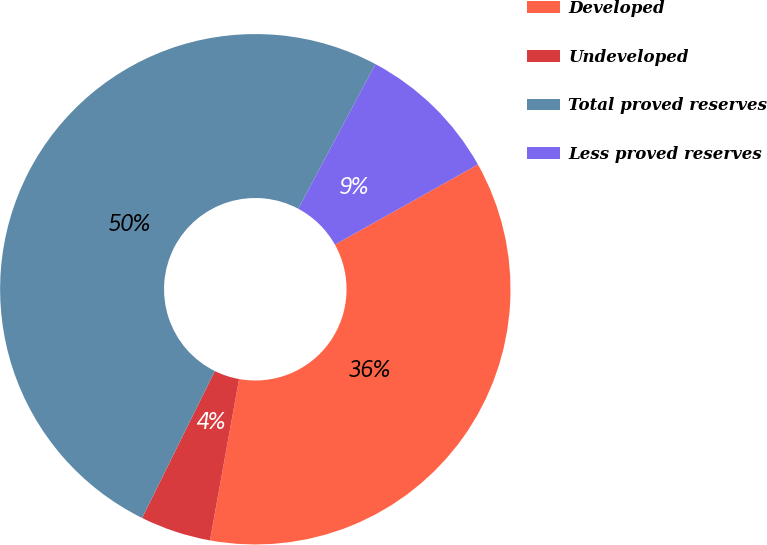Convert chart. <chart><loc_0><loc_0><loc_500><loc_500><pie_chart><fcel>Developed<fcel>Undeveloped<fcel>Total proved reserves<fcel>Less proved reserves<nl><fcel>35.97%<fcel>4.47%<fcel>50.48%<fcel>9.07%<nl></chart> 